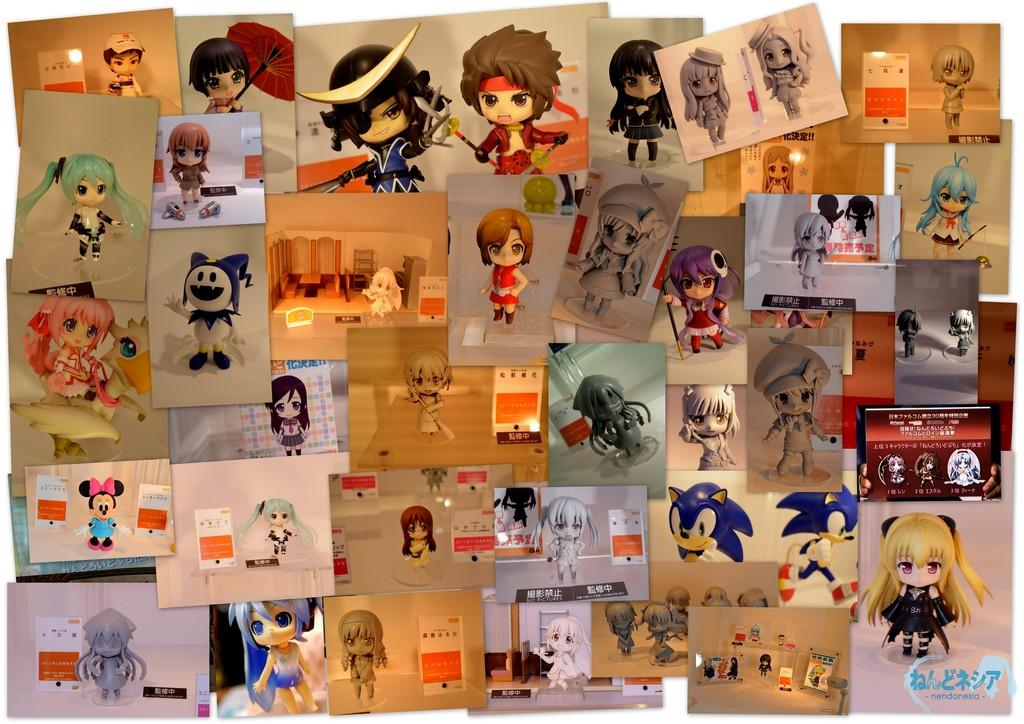What can be seen in the image in terms of visual displays? There are multiple posters in the image. How are the posters arranged in the image? The posters are arranged in a sequence. What type of images are featured on the posters? The posters contain cartoon images. What type of cough can be heard from the character in the image? There is no sound or audio in the image, so it is not possible to determine if any character is coughing or what type of cough it might be. 